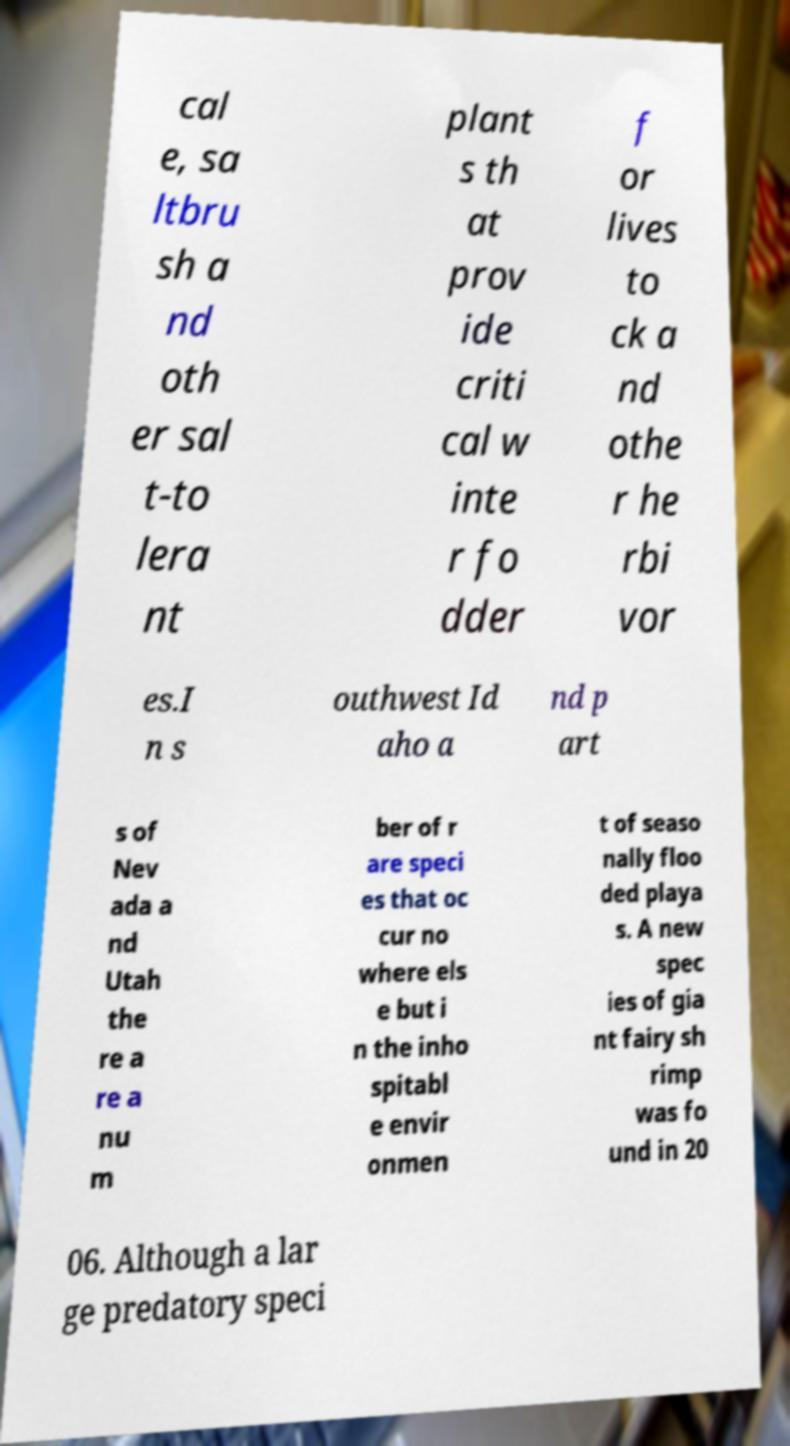I need the written content from this picture converted into text. Can you do that? cal e, sa ltbru sh a nd oth er sal t-to lera nt plant s th at prov ide criti cal w inte r fo dder f or lives to ck a nd othe r he rbi vor es.I n s outhwest Id aho a nd p art s of Nev ada a nd Utah the re a re a nu m ber of r are speci es that oc cur no where els e but i n the inho spitabl e envir onmen t of seaso nally floo ded playa s. A new spec ies of gia nt fairy sh rimp was fo und in 20 06. Although a lar ge predatory speci 